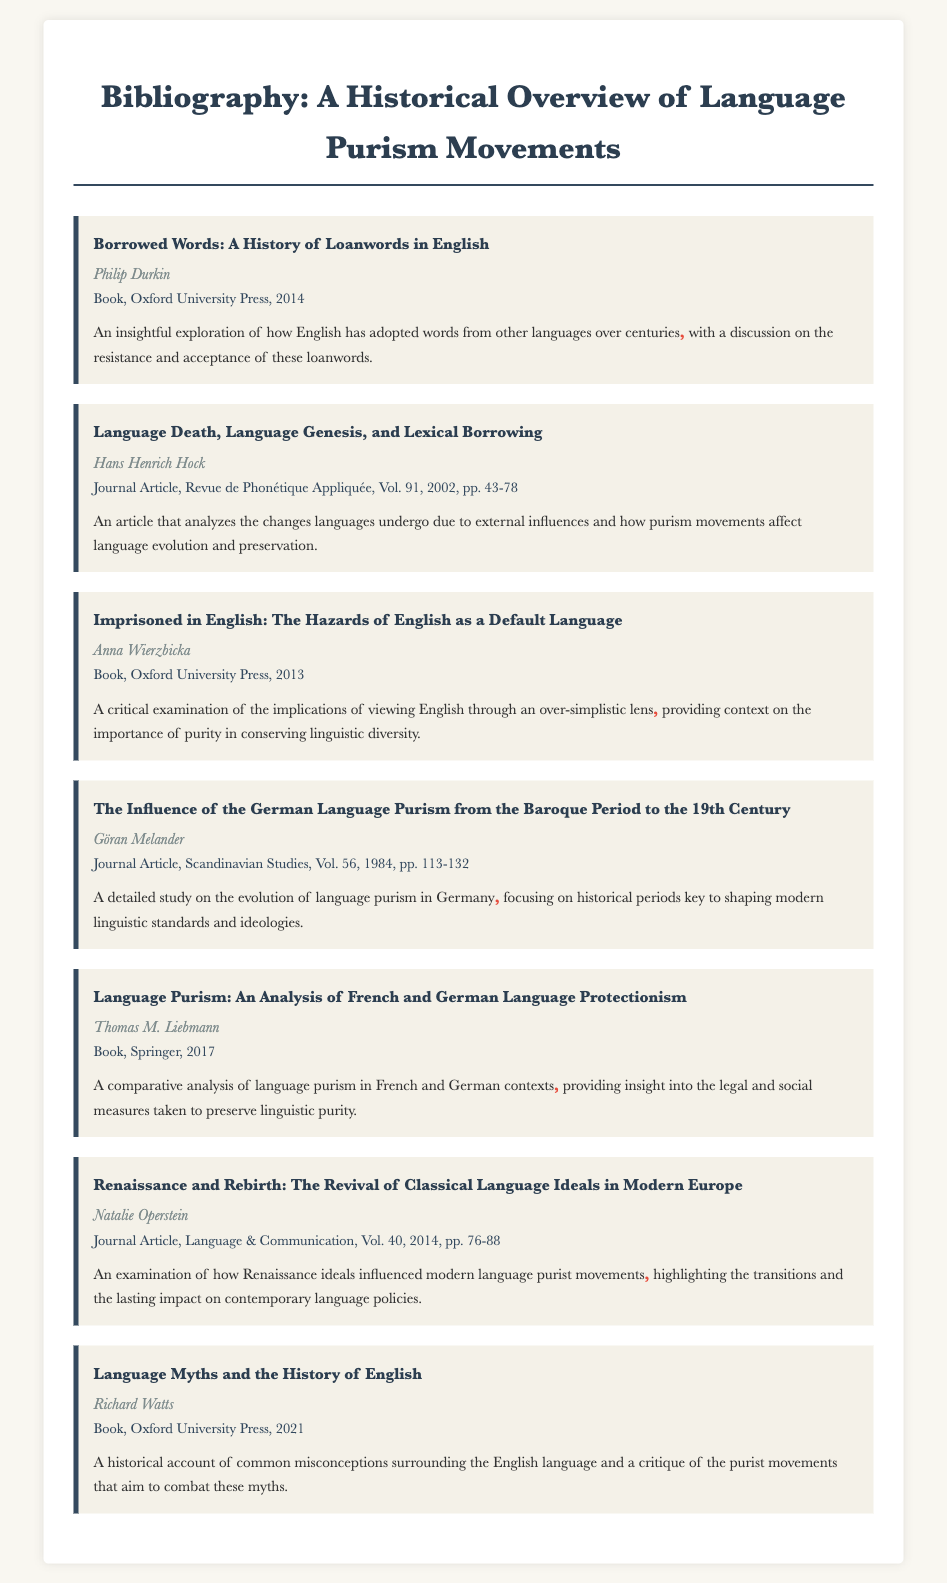What is the title of the first entry? The title of the first entry is listed at the top of the entry section, which is "Borrowed Words: A History of Loanwords in English."
Answer: Borrowed Words: A History of Loanwords in English Who is the author of the book published in 2017? The author of the book published in 2017 is mentioned in the entry details, which is Thomas M. Liebmann.
Answer: Thomas M. Liebmann What year was "Language Death, Language Genesis, and Lexical Borrowing" published? The publication year for this journal article is noted in the details, which is 2002.
Answer: 2002 What is the main focus of Anna Wierzbicka's book? The main focus is explained in the description of the entry, emphasizing the implications of viewing English simply and the importance of purity.
Answer: Importance of purity in conserving linguistic diversity Which journal contains the article "Renaissance and Rebirth"? The journal where the article is published is indicated in the document, which is "Language & Communication."
Answer: Language & Communication How many total entries are listed in the bibliography? The total number of entries can be counted from the document, which shows there are seven entries.
Answer: Seven Who published the book titled "Language Myths and the History of English"? The publisher for this book is noted in the entry details as Oxford University Press.
Answer: Oxford University Press What common theme appears in the titles of the listed works? The common theme is examined in the context of purism in language, as reflected by multiple titles addressing this issue.
Answer: Language purism 